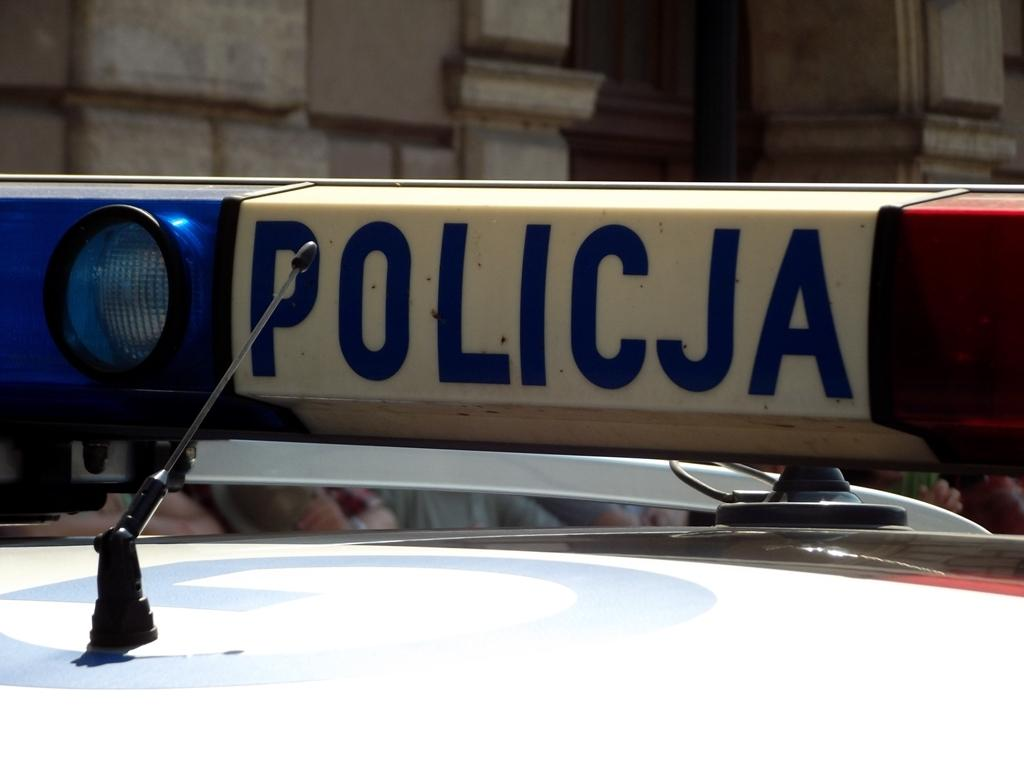What is the main subject in the image? There is a vehicle in the image. What else can be seen in the image besides the vehicle? There are buildings in the image. How many cabbages are on the bridge in the image? There is no bridge or cabbages present in the image. Can you tell me how many times the vehicle sneezes in the image? Vehicles do not sneeze, so this action cannot be observed in the image. 